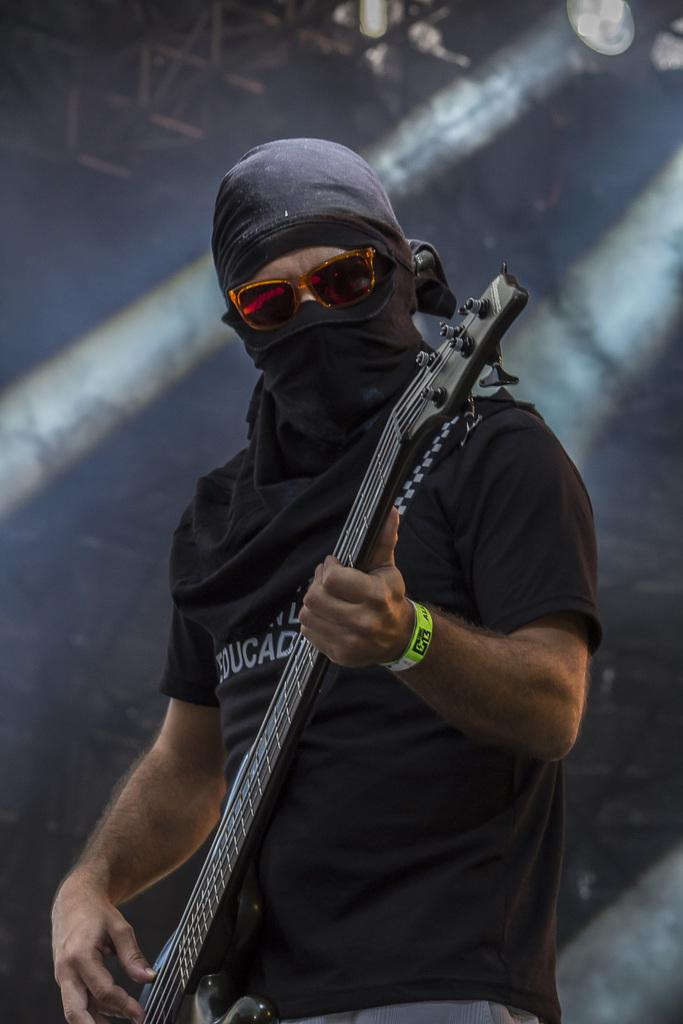What is the main subject of the image? There is a person in the image. What is the person doing in the image? The person is standing in the image. What object is the person holding in the image? The person is holding a guitar in the image. What type of collar can be seen on the person in the image? There is no collar visible on the person in the image. Can you describe the road in the image? There is no road present in the image. 